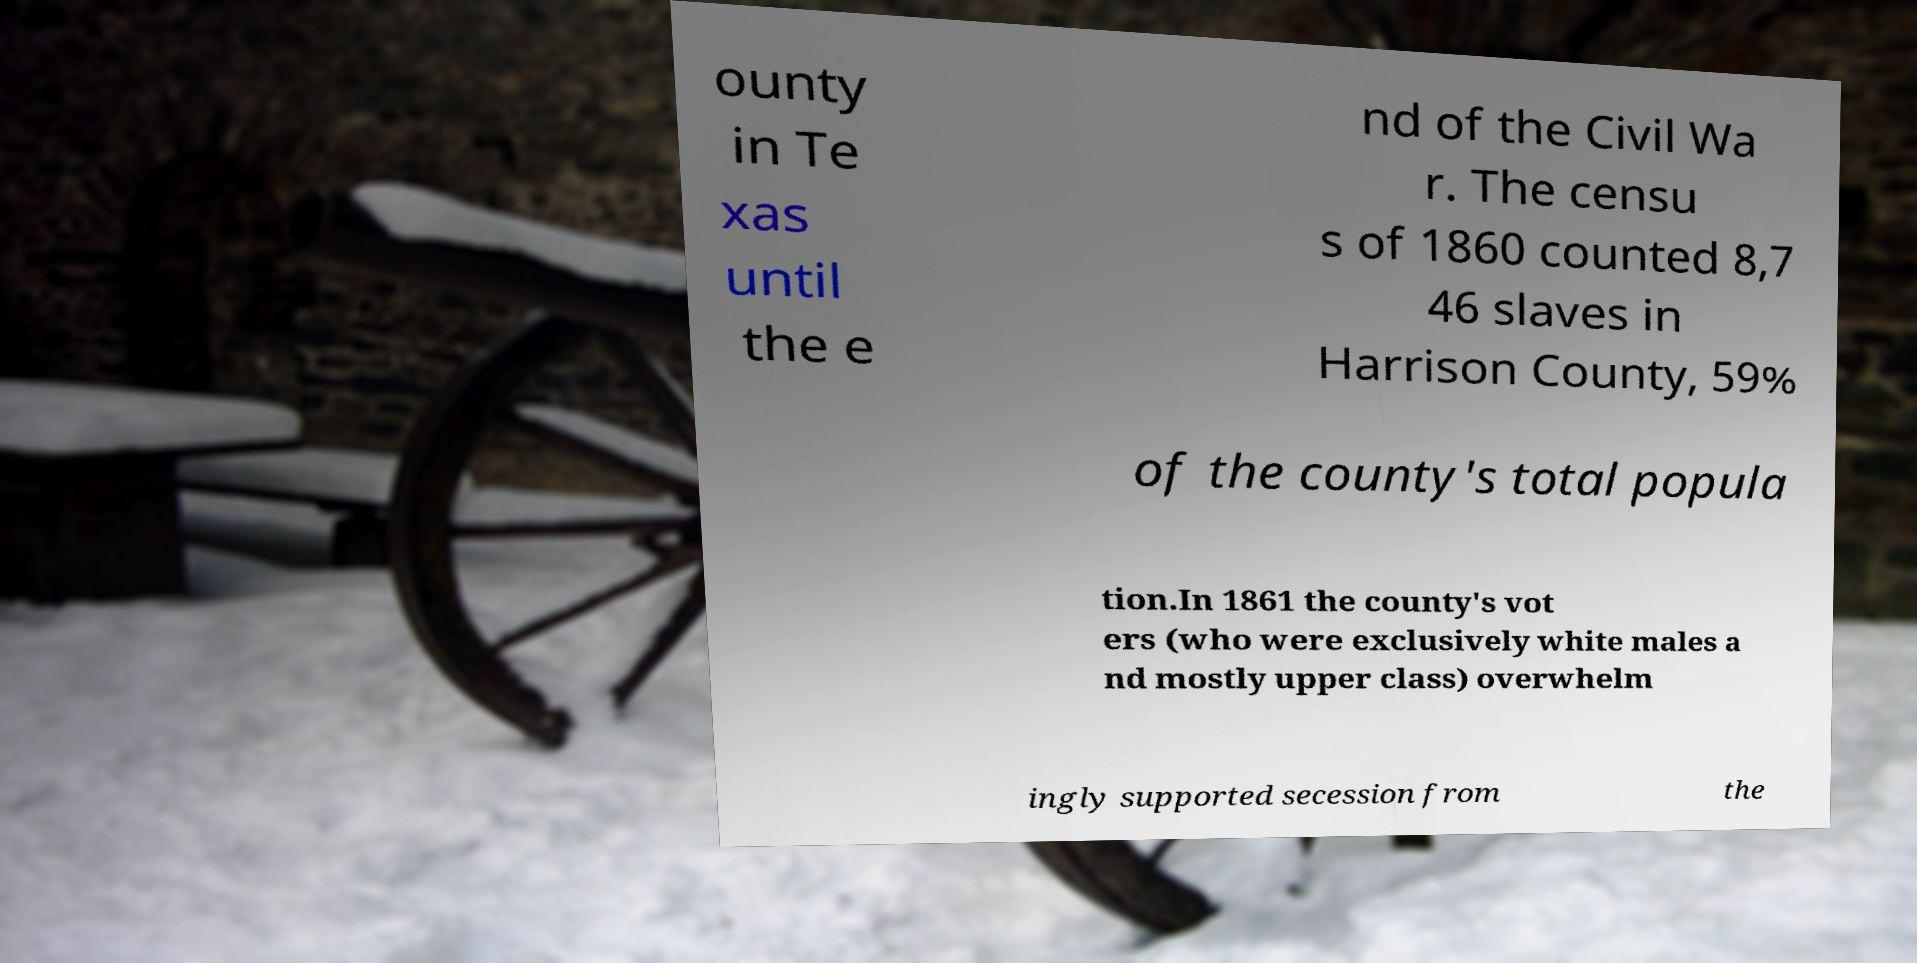Could you assist in decoding the text presented in this image and type it out clearly? ounty in Te xas until the e nd of the Civil Wa r. The censu s of 1860 counted 8,7 46 slaves in Harrison County, 59% of the county's total popula tion.In 1861 the county's vot ers (who were exclusively white males a nd mostly upper class) overwhelm ingly supported secession from the 